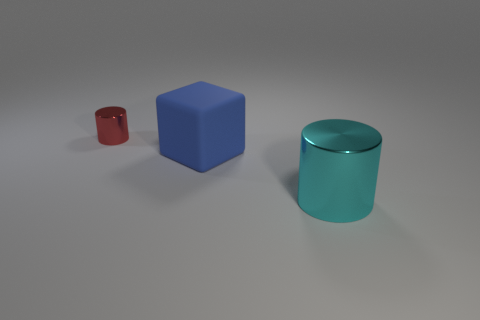Is the big thing that is in front of the blue rubber block made of the same material as the small cylinder? While the big clear object in front of the blue block and the small red cylinder may have a similar visual appearance in terms of a glossy finish, without specific material information it's impossible to confirm that they are made of the exact same material. They could be made from different types of polymers or glass with similar visual properties. 